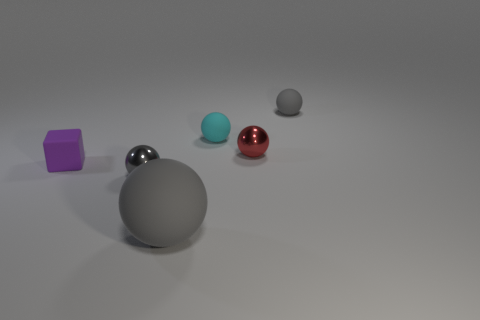How many other objects are there of the same color as the rubber cube?
Your answer should be very brief. 0. There is a block; are there any purple rubber objects in front of it?
Make the answer very short. No. The small matte sphere that is on the left side of the small gray sphere behind the tiny rubber object that is to the left of the tiny cyan ball is what color?
Offer a terse response. Cyan. What number of objects are both to the left of the big object and behind the gray shiny sphere?
Offer a very short reply. 1. What number of cylinders are large purple rubber objects or tiny metallic objects?
Your answer should be compact. 0. Is there a large red sphere?
Offer a terse response. No. What number of other objects are the same material as the small cyan sphere?
Provide a short and direct response. 3. There is a red object that is the same size as the cyan object; what is it made of?
Provide a succinct answer. Metal. There is a gray rubber thing behind the big rubber ball; does it have the same shape as the large gray matte object?
Provide a succinct answer. Yes. Do the large ball and the matte cube have the same color?
Provide a succinct answer. No. 